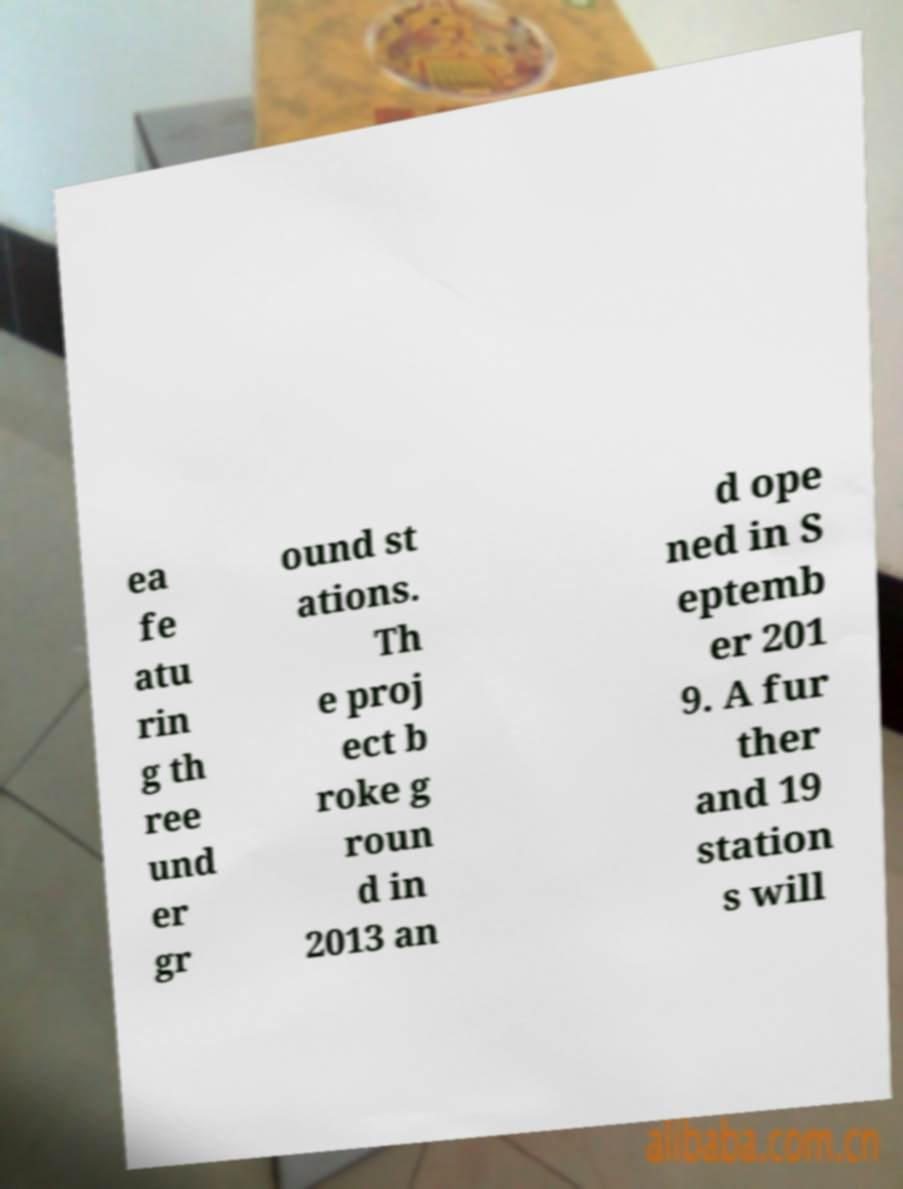Could you assist in decoding the text presented in this image and type it out clearly? ea fe atu rin g th ree und er gr ound st ations. Th e proj ect b roke g roun d in 2013 an d ope ned in S eptemb er 201 9. A fur ther and 19 station s will 